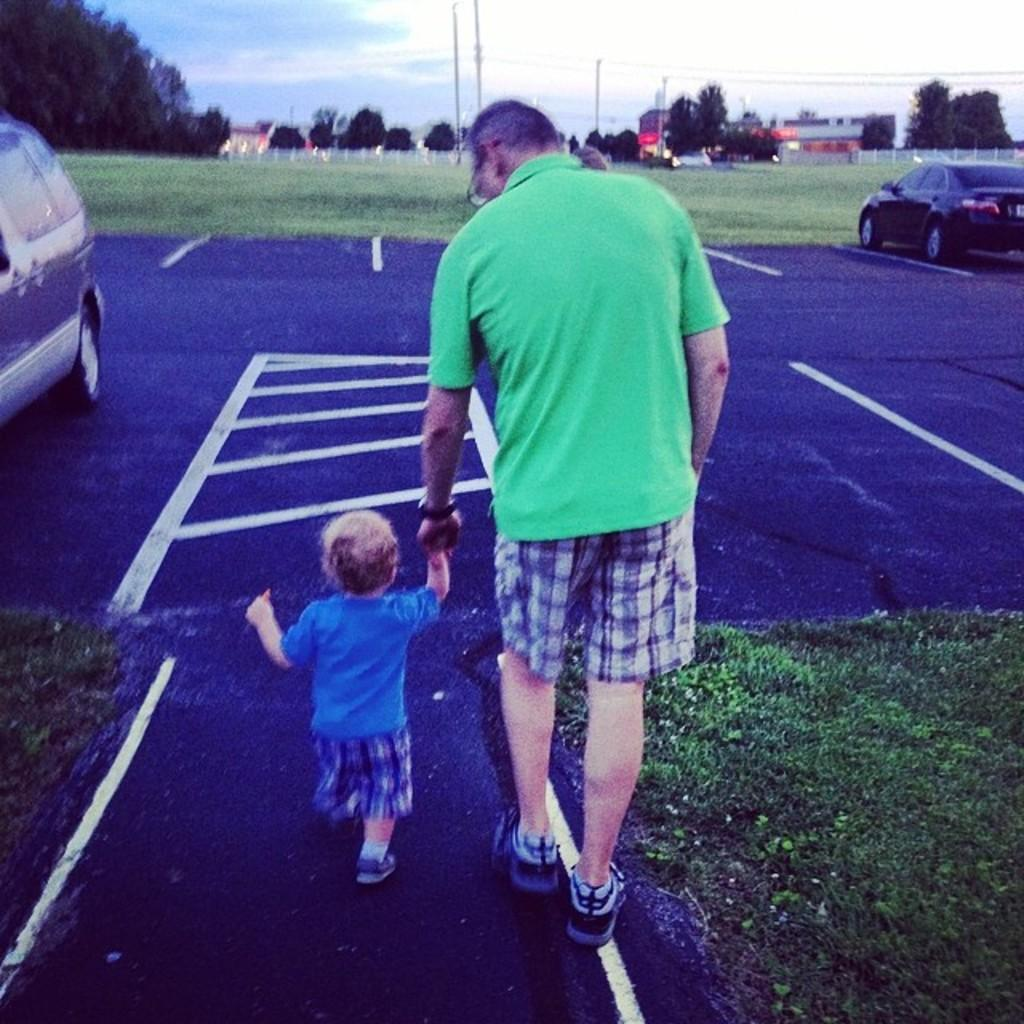Who can be seen in the image? There is a man and a kid in the image. What are they doing in the image? They are walking on the road. What else can be seen on the road in the image? Cars are visible in the image. What type of vegetation is present in the image? Grass is present in the image. What can be seen in the background of the image? There are trees, poles, fences, and the sky visible in the background of the image. Can you tell me how many quinces are hanging from the trees in the image? There are no quinces present in the image; the trees are not specified as fruit-bearing trees. How does the man touch the kid while they are walking on the road? The image does not show the man touching the kid, so it cannot be determined from the image. 